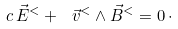Convert formula to latex. <formula><loc_0><loc_0><loc_500><loc_500>c \, \vec { E } ^ { < } + \ \vec { v } ^ { < } \land \vec { B } ^ { < } = 0 \, \cdot</formula> 